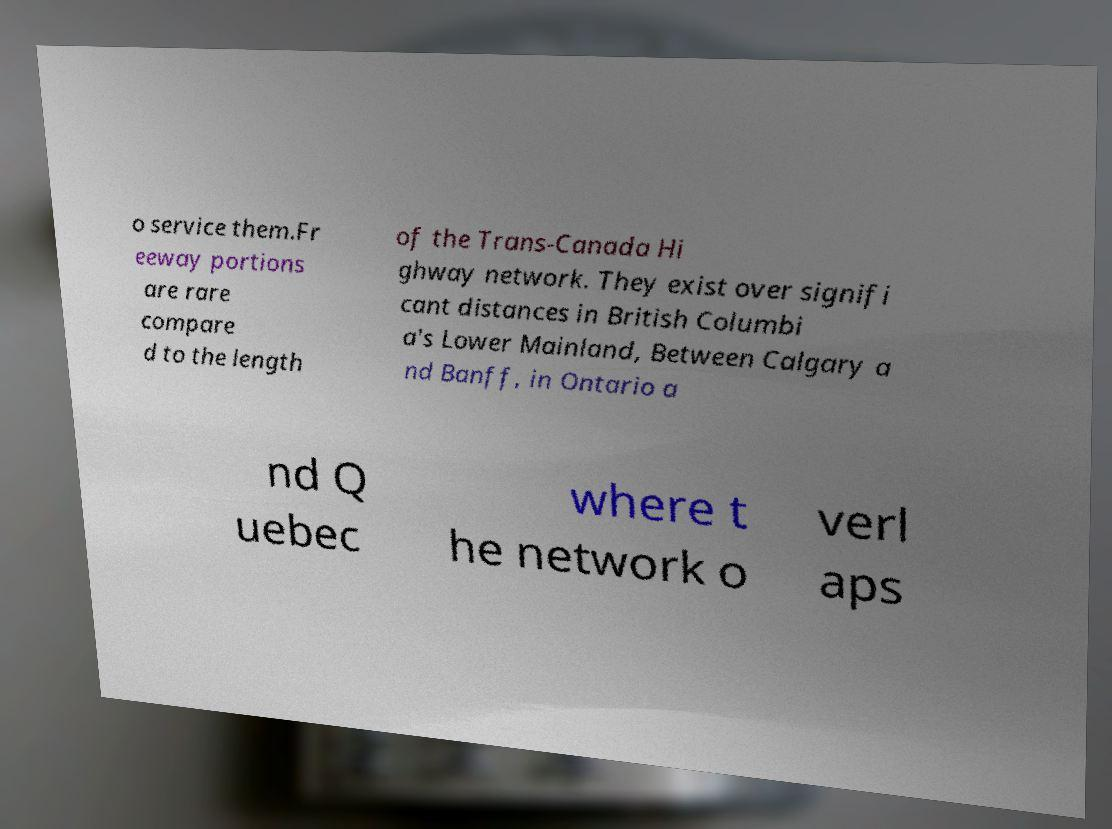Could you extract and type out the text from this image? o service them.Fr eeway portions are rare compare d to the length of the Trans-Canada Hi ghway network. They exist over signifi cant distances in British Columbi a's Lower Mainland, Between Calgary a nd Banff, in Ontario a nd Q uebec where t he network o verl aps 